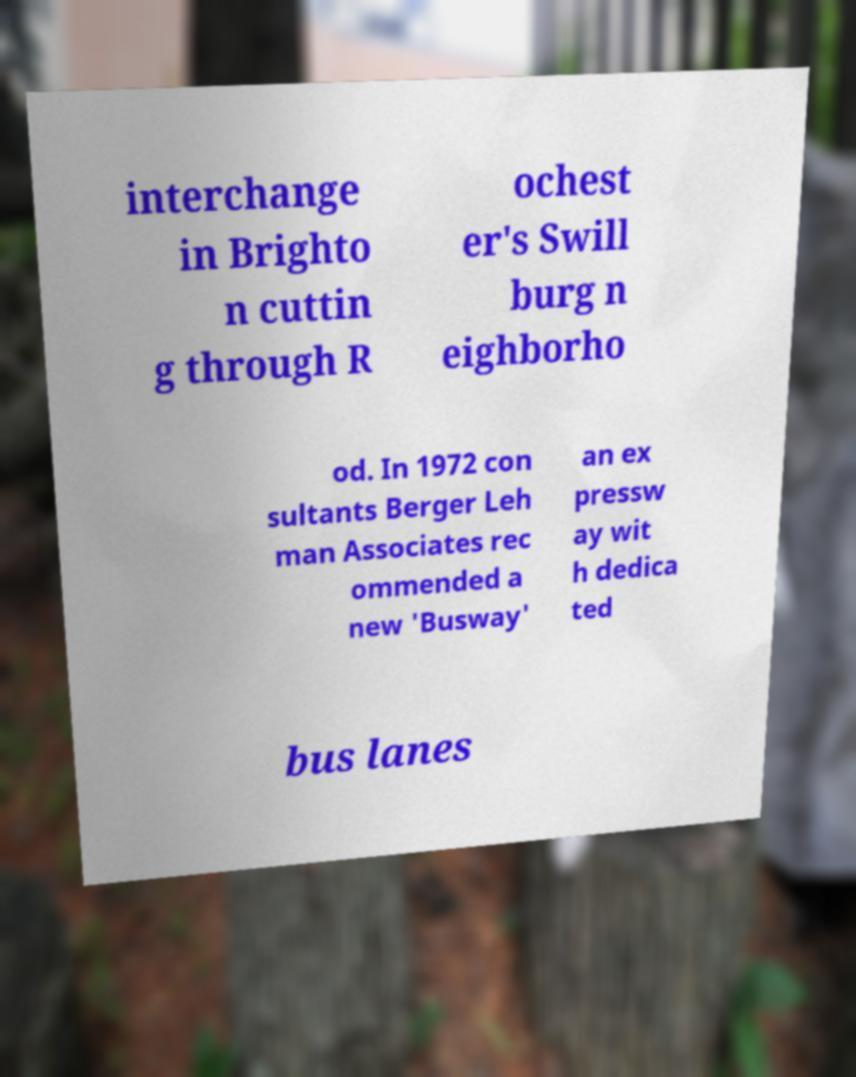Please read and relay the text visible in this image. What does it say? interchange in Brighto n cuttin g through R ochest er's Swill burg n eighborho od. In 1972 con sultants Berger Leh man Associates rec ommended a new 'Busway' an ex pressw ay wit h dedica ted bus lanes 